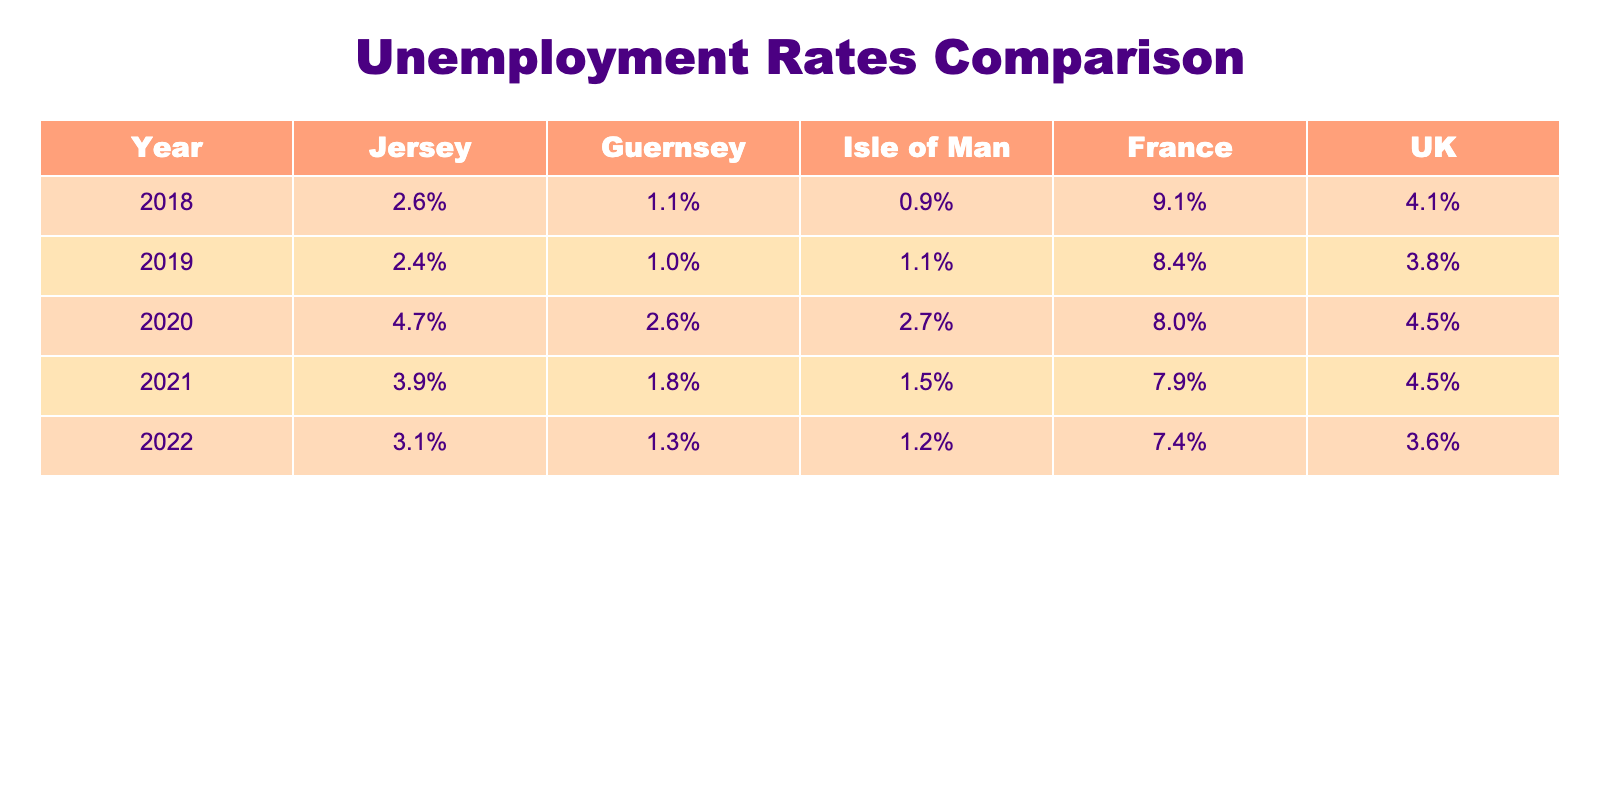What was Jersey's unemployment rate in 2020? The table shows that Jersey's unemployment rate for the year 2020 is listed as 4.7%.
Answer: 4.7% Which region had the lowest unemployment rate in 2021? Looking at the column for the year 2021, we can see that Guernsey had the lowest unemployment rate of 1.8%.
Answer: Guernsey How much higher was Jersey's unemployment rate in 2020 compared to Guernsey's? In 2020, Jersey's unemployment rate was 4.7%, while Guernsey's was 2.6%. The difference is 4.7% - 2.6% = 2.1%.
Answer: 2.1% What was the average unemployment rate for the Isle of Man over the 5 years? To find the average unemployment rate for the Isle of Man, we add up the rates for each year: (0.9% + 1.1% + 2.7% + 1.5% + 1.2%) and divide by 5, which results in an average of 1.48%.
Answer: 1.48% Did Jersey's unemployment rate increase from 2019 to 2020? By comparing the rates for those years, Jersey's rate was 2.4% in 2019 and 4.7% in 2020, which indicates an increase.
Answer: Yes What is the trend of unemployment rates in Jersey from 2018 to 2022? The rates show a change from 2.6% in 2018 to 3.1% in 2022, with a peak in 2020 at 4.7%, followed by a decrease in subsequent years, indicating a fluctuation trend.
Answer: Fluctuation trend Which region consistently had the lowest unemployment rates from 2018 to 2022? By examining the data, Guernsey shows the lowest rates consistently across all the given years, ranging from 1.0% to 1.3%.
Answer: Guernsey In what year did the UK have its highest unemployment rate, and what was it? The table indicates that the UK's highest unemployment rate was in 2018, at 4.1%.
Answer: 2018, 4.1% What are the unemployment rate differences between Jersey and the UK for the year 2022? In 2022, Jersey's unemployment rate was 3.1% and the UK's was 3.6%. The difference is 3.1% - 3.6% = -0.5%, meaning Jersey's rate was lower.
Answer: -0.5% How did the unemployment rate of France compare to that of the Isle of Man in 2019? In 2019, France's rate was 8.4% whereas the Isle of Man's was 1.1%. The comparison shows that France had a significantly higher unemployment rate.
Answer: France had a higher rate 